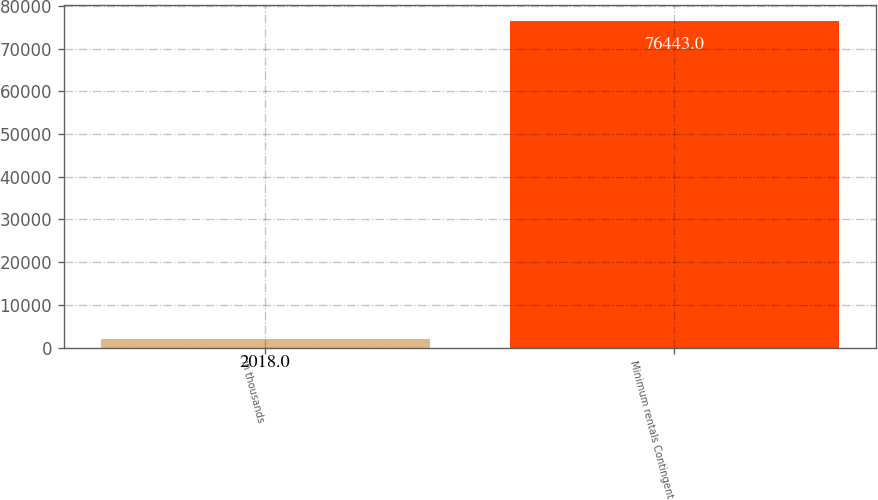Convert chart. <chart><loc_0><loc_0><loc_500><loc_500><bar_chart><fcel>in thousands<fcel>Minimum rentals Contingent<nl><fcel>2018<fcel>76443<nl></chart> 